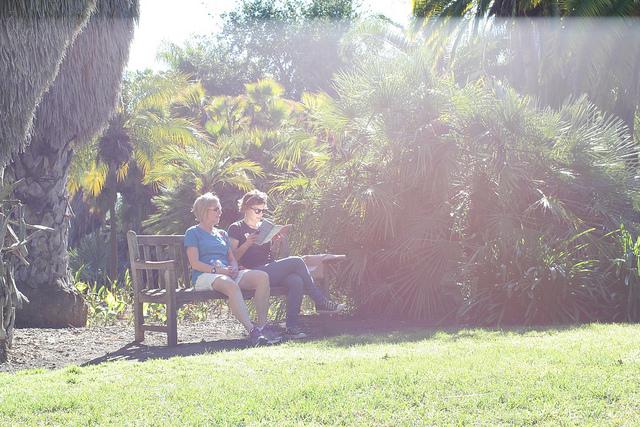What are they sitting on?
Keep it brief. Bench. What is the weather like?
Write a very short answer. Sunny. Is that a palm tree?
Be succinct. Yes. How many people are reading in the photo?
Short answer required. 1. 